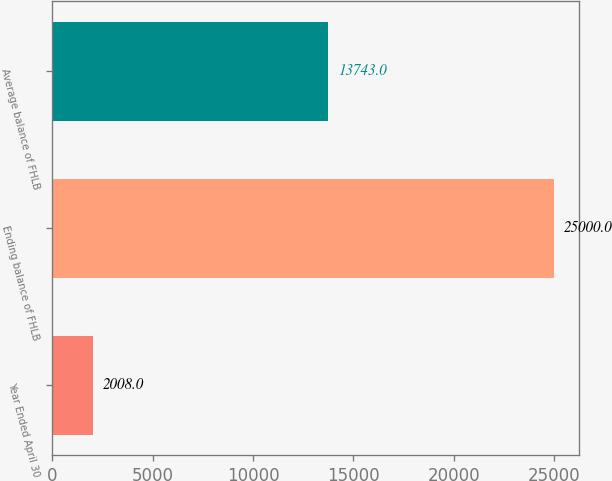Convert chart. <chart><loc_0><loc_0><loc_500><loc_500><bar_chart><fcel>Year Ended April 30<fcel>Ending balance of FHLB<fcel>Average balance of FHLB<nl><fcel>2008<fcel>25000<fcel>13743<nl></chart> 